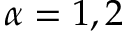Convert formula to latex. <formula><loc_0><loc_0><loc_500><loc_500>\alpha = 1 , 2</formula> 